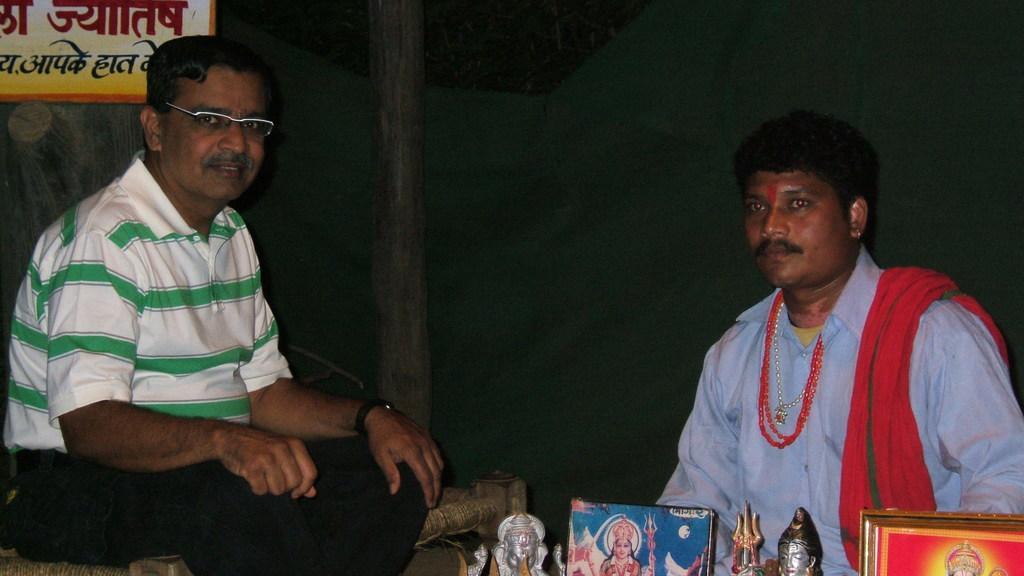Can you describe this image briefly? In this image I can see two persons and I can also see few statues and few frames, the board and I can see the dark background. 